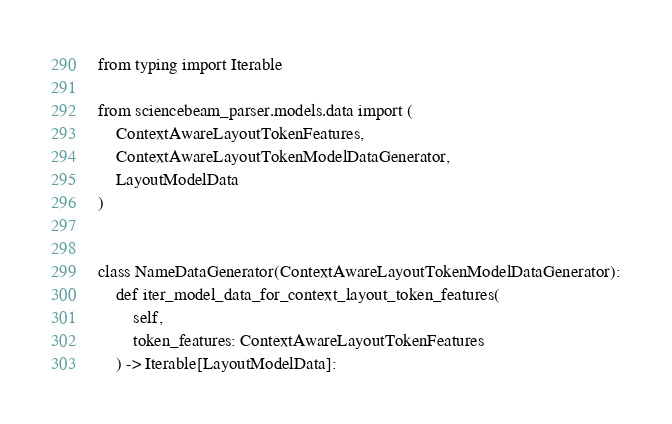Convert code to text. <code><loc_0><loc_0><loc_500><loc_500><_Python_>from typing import Iterable

from sciencebeam_parser.models.data import (
    ContextAwareLayoutTokenFeatures,
    ContextAwareLayoutTokenModelDataGenerator,
    LayoutModelData
)


class NameDataGenerator(ContextAwareLayoutTokenModelDataGenerator):
    def iter_model_data_for_context_layout_token_features(
        self,
        token_features: ContextAwareLayoutTokenFeatures
    ) -> Iterable[LayoutModelData]:</code> 